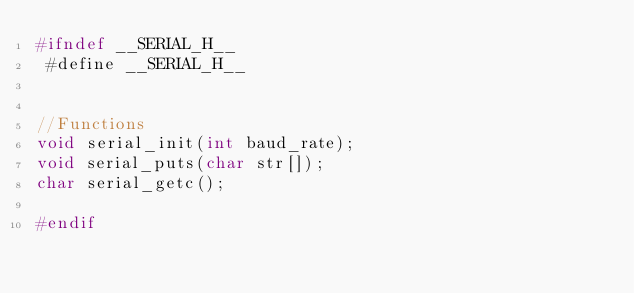<code> <loc_0><loc_0><loc_500><loc_500><_C_>#ifndef __SERIAL_H__
 #define __SERIAL_H__


//Functions
void serial_init(int baud_rate);
void serial_puts(char str[]);
char serial_getc();

#endif
</code> 